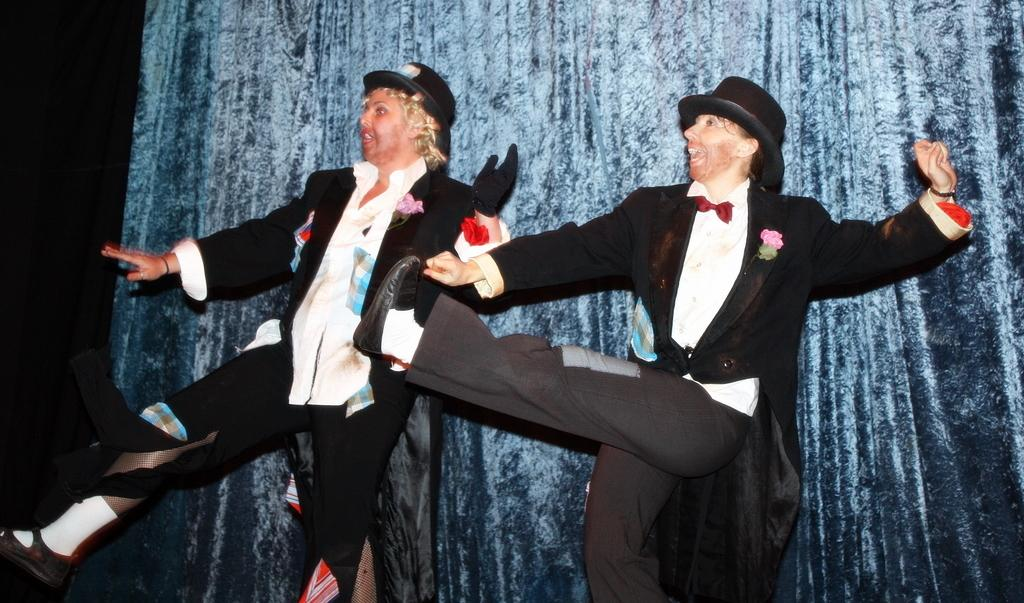How many people are in the image? There are two persons in the image. What are the persons doing in the image? The persons are dancing. What can be seen on the dresses of the persons? There are flowers on their dresses. What can be seen in the background of the image? There is a curtain visible in the background of the image. How many baby ducks are visible in the image? There are no baby ducks present in the image. What role does the cast play in the image? There is no mention of a cast or any theatrical performance in the image. 